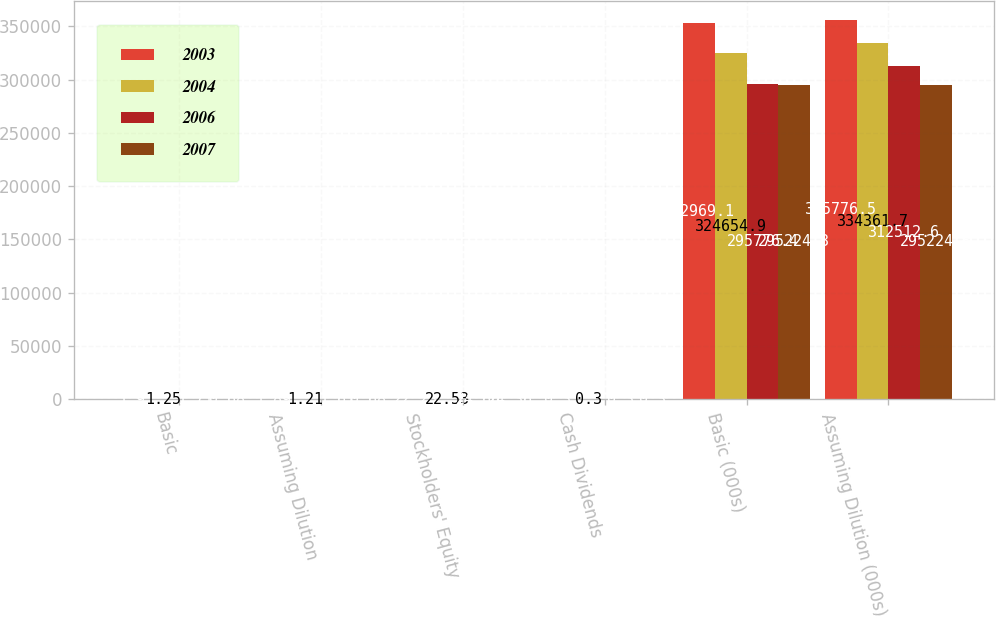<chart> <loc_0><loc_0><loc_500><loc_500><stacked_bar_chart><ecel><fcel>Basic<fcel>Assuming Dilution<fcel>Stockholders' Equity<fcel>Cash Dividends<fcel>Basic (000s)<fcel>Assuming Dilution (000s)<nl><fcel>2003<fcel>1.9<fcel>1.89<fcel>22.28<fcel>0.3<fcel>352969<fcel>355776<nl><fcel>2004<fcel>1.25<fcel>1.21<fcel>22.53<fcel>0.3<fcel>324655<fcel>334362<nl><fcel>2006<fcel>1.71<fcel>1.61<fcel>24.66<fcel>0.3<fcel>295776<fcel>312513<nl><fcel>2007<fcel>0.68<fcel>0.68<fcel>24.36<fcel>0.3<fcel>295224<fcel>295224<nl></chart> 